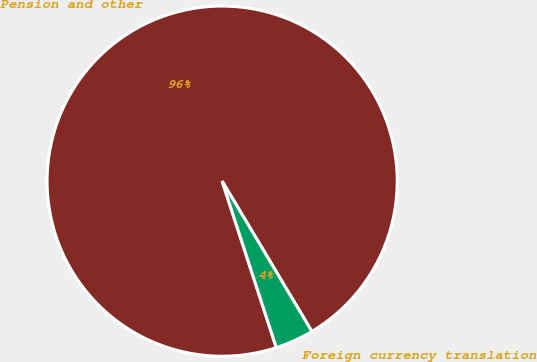Convert chart to OTSL. <chart><loc_0><loc_0><loc_500><loc_500><pie_chart><fcel>Pension and other<fcel>Foreign currency translation<nl><fcel>96.44%<fcel>3.56%<nl></chart> 